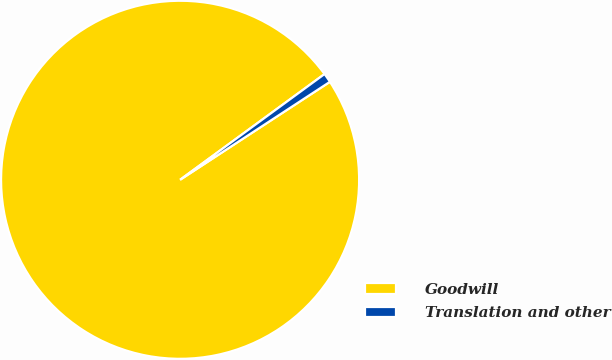<chart> <loc_0><loc_0><loc_500><loc_500><pie_chart><fcel>Goodwill<fcel>Translation and other<nl><fcel>99.16%<fcel>0.84%<nl></chart> 